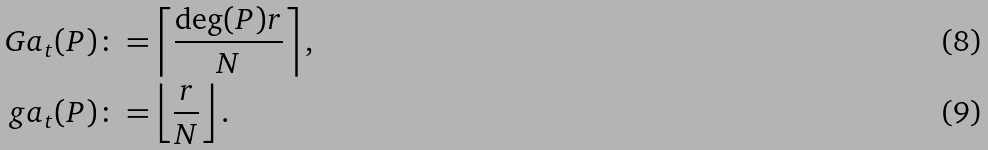<formula> <loc_0><loc_0><loc_500><loc_500>\ G a _ { t } ( P ) & \colon = \left \lceil \frac { \deg ( P ) r } { N } \right \rceil , \\ \ g a _ { t } ( P ) & \colon = \left \lfloor \frac { r } { N } \right \rfloor .</formula> 